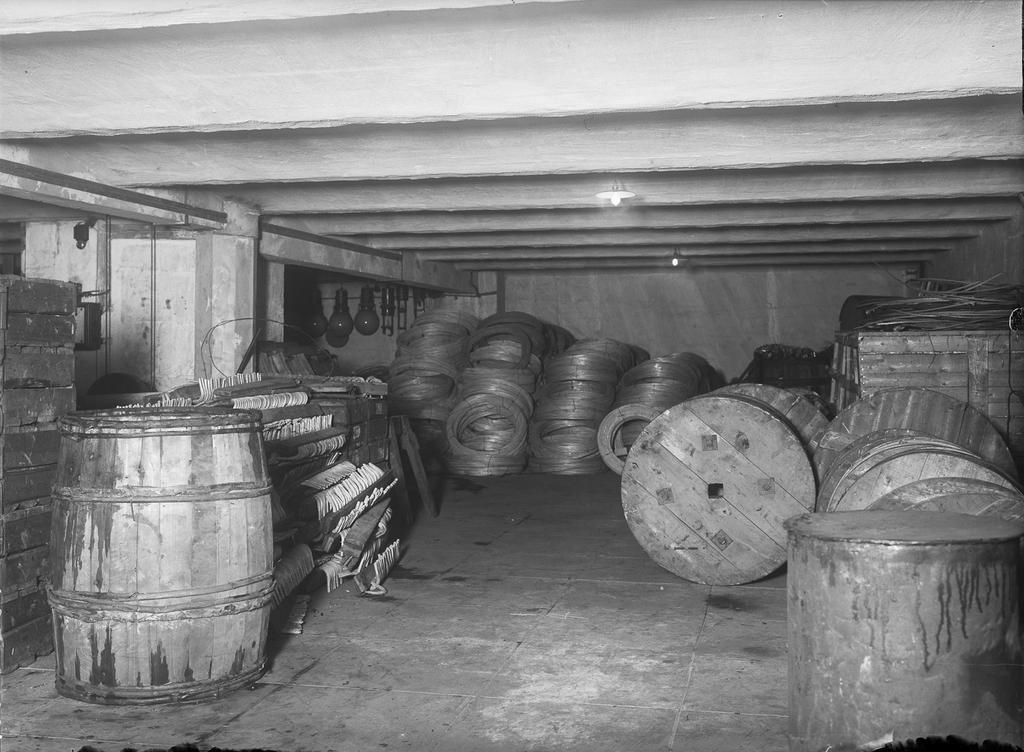In one or two sentences, can you explain what this image depicts? In this image we can see barrels, wooden bars, wounded wires and electric lights. 